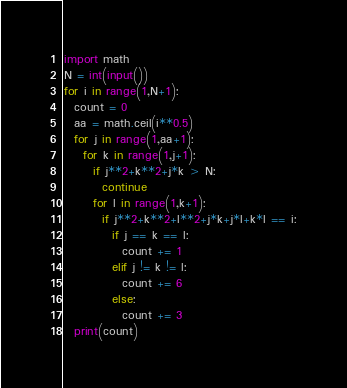<code> <loc_0><loc_0><loc_500><loc_500><_Python_>import math
N = int(input())
for i in range(1,N+1):
  count = 0
  aa = math.ceil(i**0.5)
  for j in range(1,aa+1):
    for k in range(1,j+1):
      if j**2+k**2+j*k > N:
        continue
      for l in range(1,k+1):
        if j**2+k**2+l**2+j*k+j*l+k*l == i:
          if j == k == l:
            count += 1
          elif j != k != l:
            count += 6
          else:
            count += 3
  print(count)</code> 